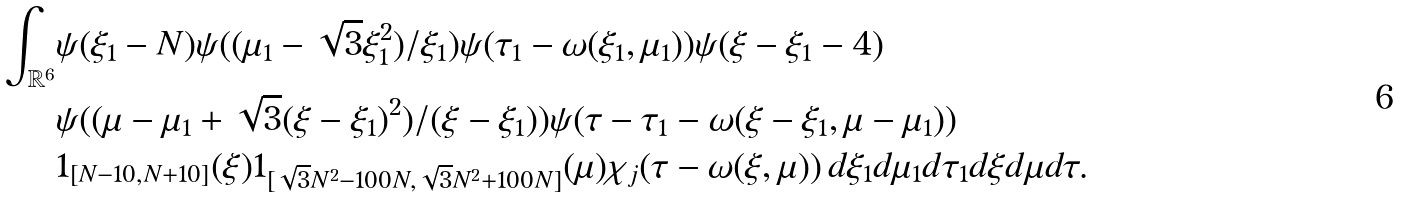Convert formula to latex. <formula><loc_0><loc_0><loc_500><loc_500>\int _ { \mathbb { R } ^ { 6 } } & \psi ( \xi _ { 1 } - N ) \psi ( ( \mu _ { 1 } - \sqrt { 3 } \xi _ { 1 } ^ { 2 } ) / \xi _ { 1 } ) \psi ( \tau _ { 1 } - \omega ( \xi _ { 1 } , \mu _ { 1 } ) ) \psi ( \xi - \xi _ { 1 } - 4 ) \\ & \psi ( ( \mu - \mu _ { 1 } + \sqrt { 3 } ( \xi - \xi _ { 1 } ) ^ { 2 } ) / ( \xi - \xi _ { 1 } ) ) \psi ( \tau - \tau _ { 1 } - \omega ( \xi - \xi _ { 1 } , \mu - \mu _ { 1 } ) ) \\ & 1 _ { [ N - 1 0 , N + 1 0 ] } ( \xi ) 1 _ { [ \sqrt { 3 } N ^ { 2 } - 1 0 0 N , \sqrt { 3 } N ^ { 2 } + 1 0 0 N ] } ( \mu ) \chi _ { j } ( \tau - \omega ( \xi , \mu ) ) \, d \xi _ { 1 } d \mu _ { 1 } d \tau _ { 1 } d \xi d \mu d \tau .</formula> 